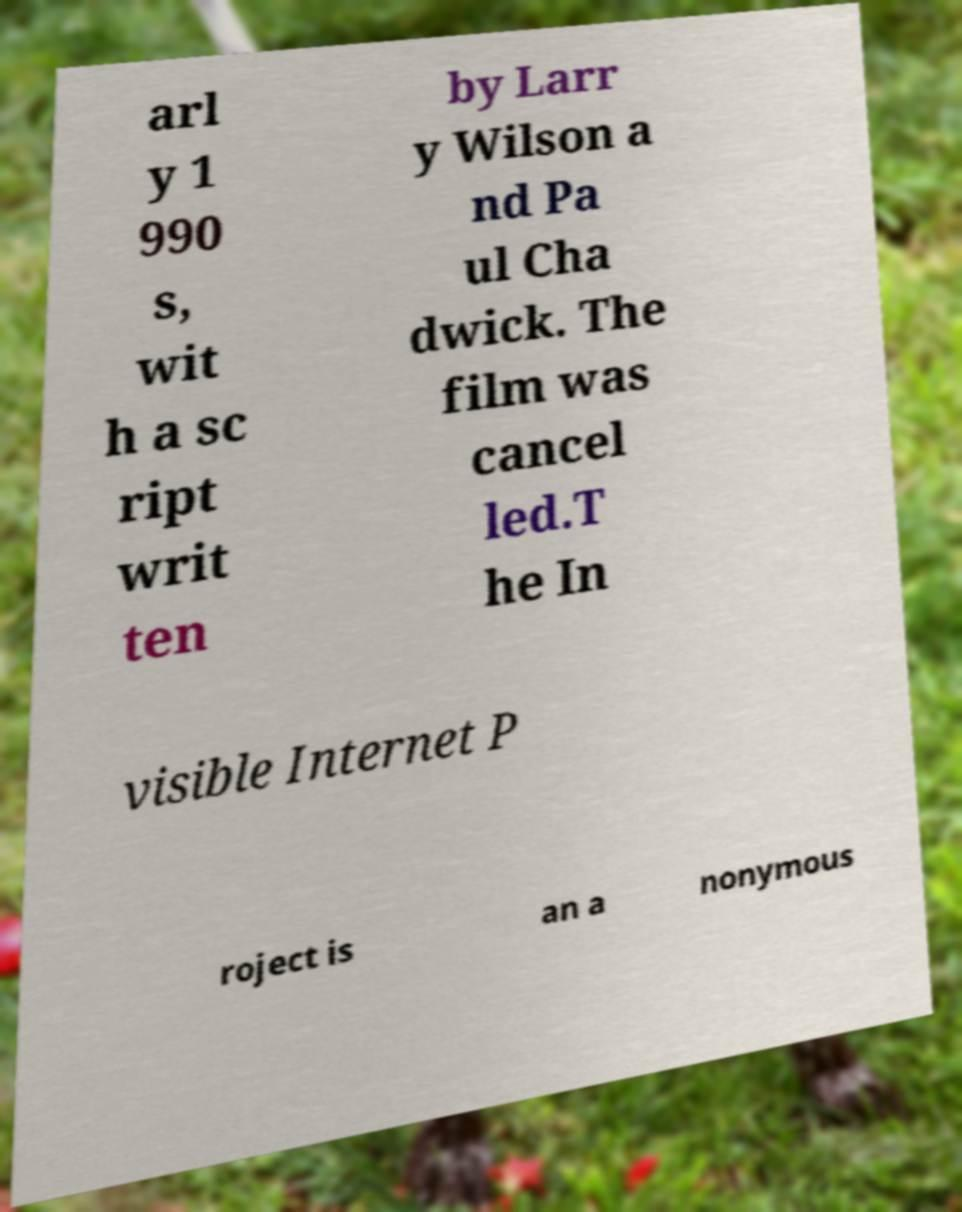For documentation purposes, I need the text within this image transcribed. Could you provide that? arl y 1 990 s, wit h a sc ript writ ten by Larr y Wilson a nd Pa ul Cha dwick. The film was cancel led.T he In visible Internet P roject is an a nonymous 